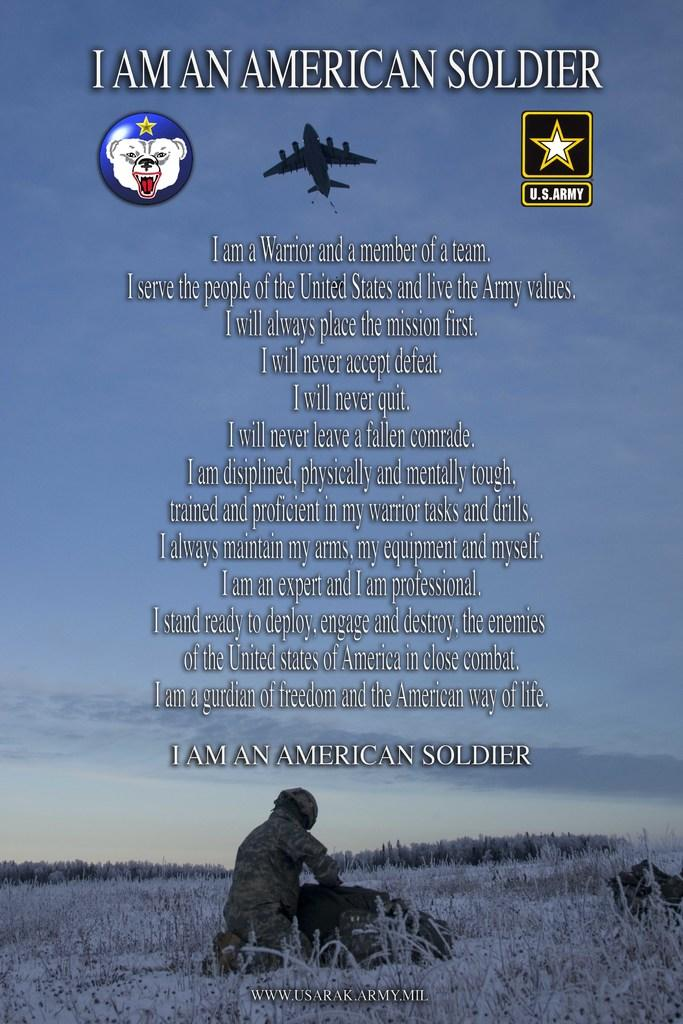<image>
Relay a brief, clear account of the picture shown. A poem with a sad picture of a fallen solder is called I am a American Soldier. 